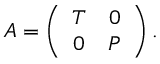<formula> <loc_0><loc_0><loc_500><loc_500>A = \left ( \begin{array} { c c } { T } & { 0 } \\ { 0 } & { P } \end{array} \right ) .</formula> 